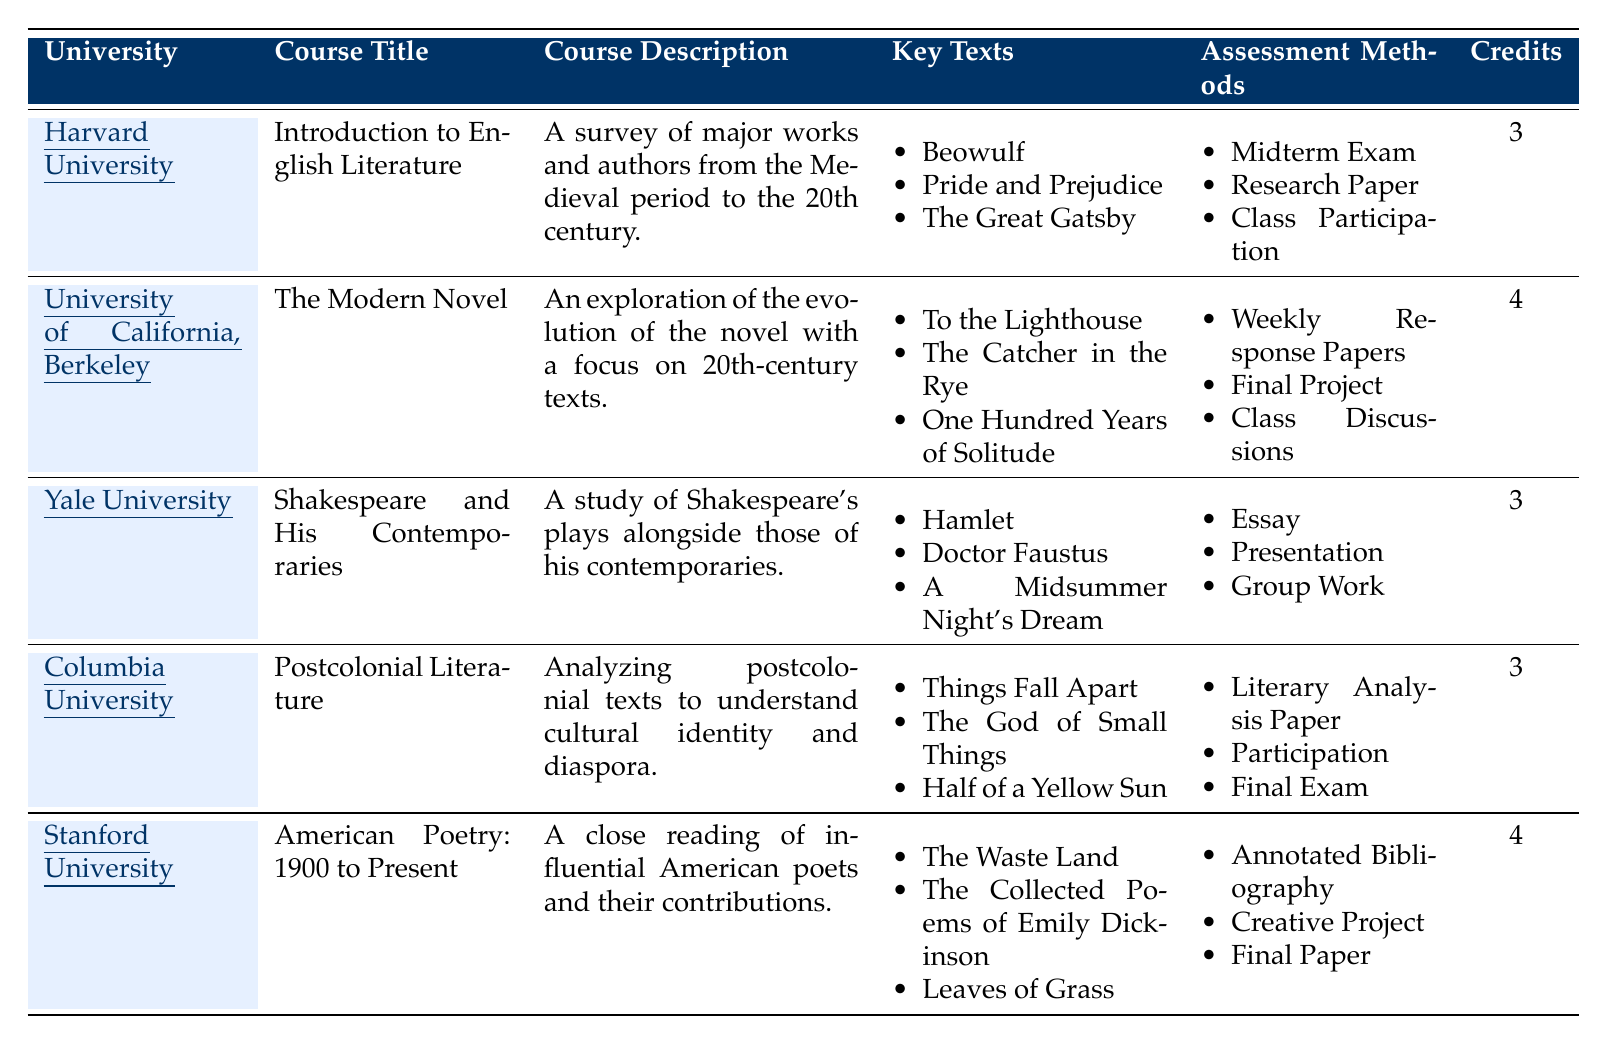What is the course title offered by Harvard University? The table explicitly lists the course title associated with Harvard University in the "Course Title" column. It states "Introduction to English Literature."
Answer: Introduction to English Literature How many credits is the course "The Modern Novel" worth? By examining the table, we can see that the course "The Modern Novel" is associated with "University of California, Berkeley," and refers back to its "Credits" column, which states it is worth 4 credits.
Answer: 4 Which university offers a course that includes "Hamlet" as a key text? The key texts for each course are listed in the table; "Hamlet" is included in the key texts for the course offered by Yale University titled "Shakespeare and His Contemporaries."
Answer: Yale University What are the assessment methods for the course titled "Postcolonial Literature"? The table details the assessment methods for "Postcolonial Literature" under "Assessment Methods" section, which includes "Literary Analysis Paper," "Participation," and "Final Exam."
Answer: Literary Analysis Paper, Participation, Final Exam Which course has the largest credit value, and what is that value? We can compare the credit values listed for each course. The highest value among them is 4 credits, found in the courses "The Modern Novel" and "American Poetry: 1900 to Present."
Answer: 4 Count the total number of courses offered in the table. By counting each entry in the table, we find there are 5 distinct courses listed across different universities.
Answer: 5 Is Stanford University offering a course related to poetry? Looking at the table, we find that "American Poetry: 1900 to Present" is indeed a course offered by Stanford University, which confirms that they have a poetry-related course.
Answer: Yes Which university has the course description focusing on cultural identity and diaspora? The course description specifically encompassing cultural identity and diaspora is found in the course titled "Postcolonial Literature," which is linked to Columbia University.
Answer: Columbia University Determine the average credits for the courses listed. To calculate the average, we sum the credits (3 + 4 + 3 + 3 + 4 = 17) and divide by the number of courses (5), yielding an average of 3.4.
Answer: 3.4 Does any course have a midterm exam as part of its assessment methods? The assessment methods for the "Introduction to English Literature" course at Harvard University include "Midterm Exam," indicating that at least one course does have this component.
Answer: Yes Which course has both a "Final Exam" and a "Research Paper"? By examining the assessment methods in the table, we find that "Postcolonial Literature" has a "Final Exam," and "Introduction to English Literature" has a "Research Paper." However, neither course contains both methods.
Answer: None 